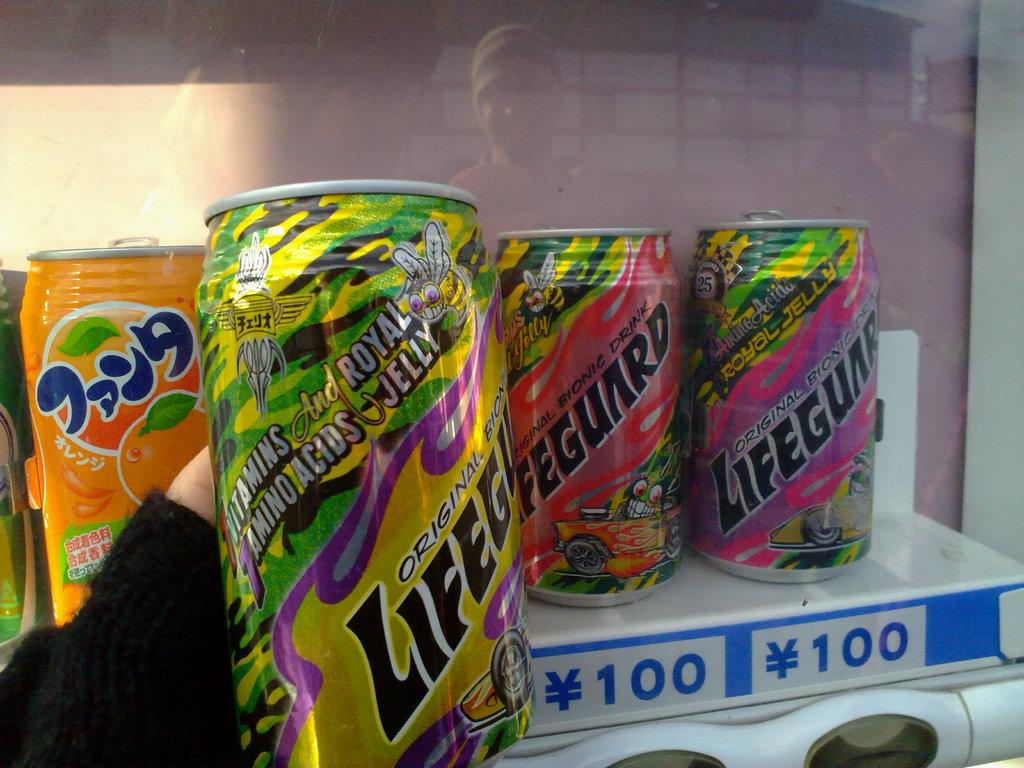What brand of soda is this?
Offer a terse response. Lifeguard. What is advertised on the front can?
Keep it short and to the point. Lifeguard. 